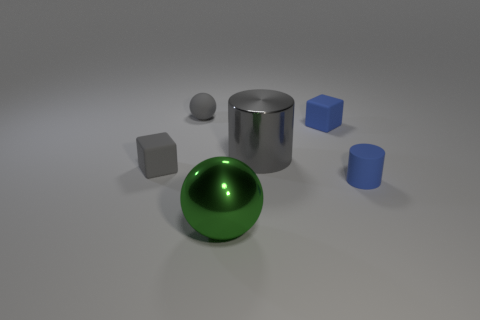Subtract all spheres. How many objects are left? 4 Add 4 blue rubber cylinders. How many objects exist? 10 Subtract all big purple metallic spheres. Subtract all small gray matte things. How many objects are left? 4 Add 2 large green objects. How many large green objects are left? 3 Add 3 small gray metal cylinders. How many small gray metal cylinders exist? 3 Subtract 1 blue cylinders. How many objects are left? 5 